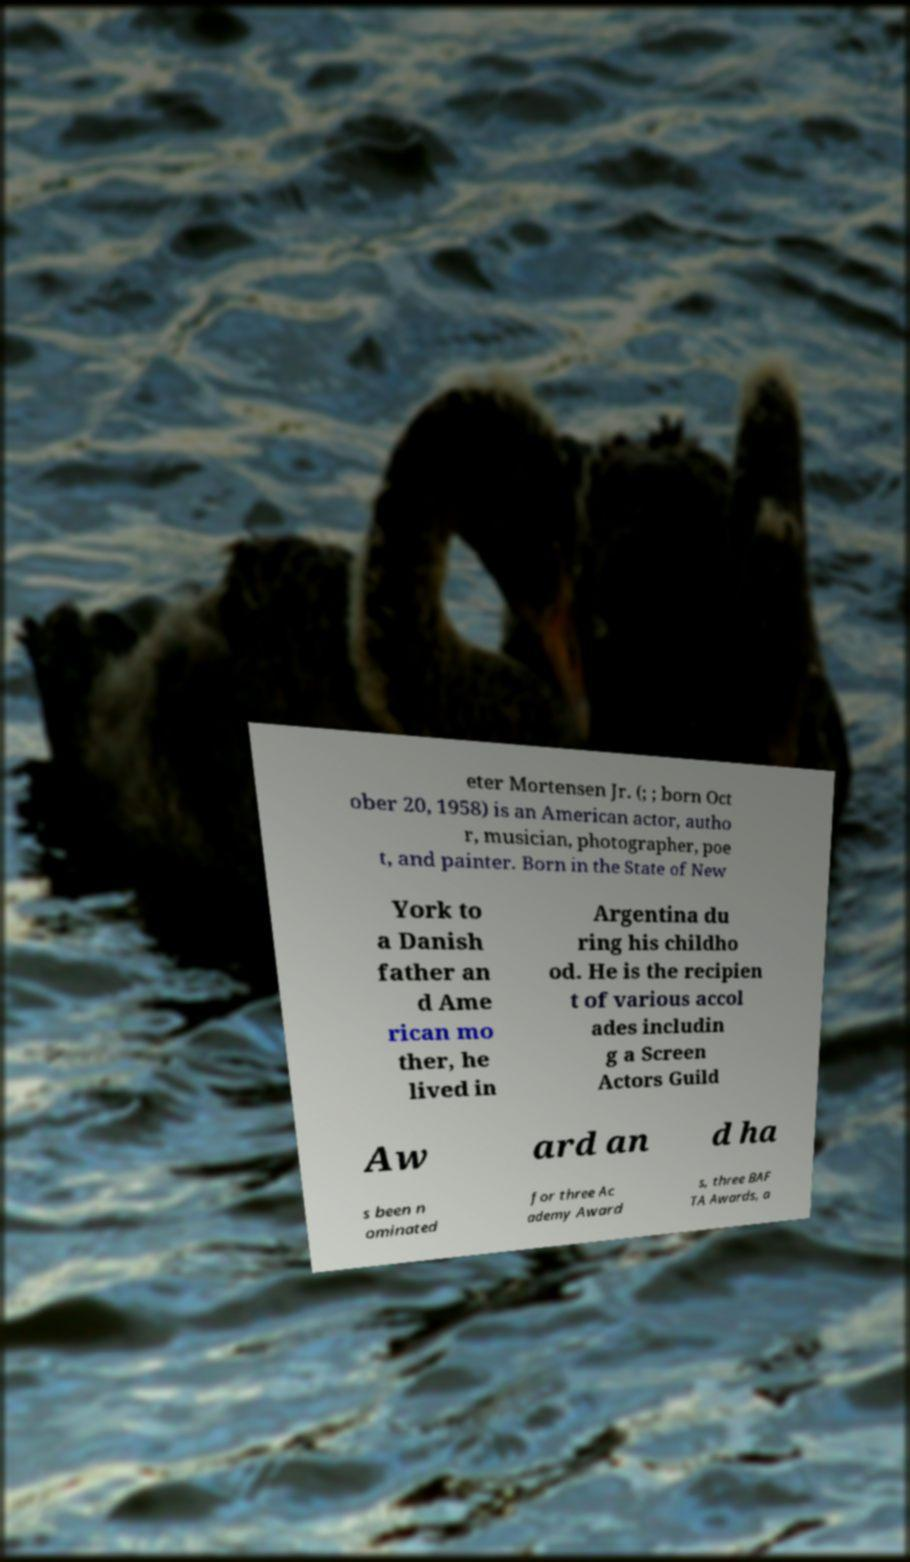There's text embedded in this image that I need extracted. Can you transcribe it verbatim? eter Mortensen Jr. (; ; born Oct ober 20, 1958) is an American actor, autho r, musician, photographer, poe t, and painter. Born in the State of New York to a Danish father an d Ame rican mo ther, he lived in Argentina du ring his childho od. He is the recipien t of various accol ades includin g a Screen Actors Guild Aw ard an d ha s been n ominated for three Ac ademy Award s, three BAF TA Awards, a 